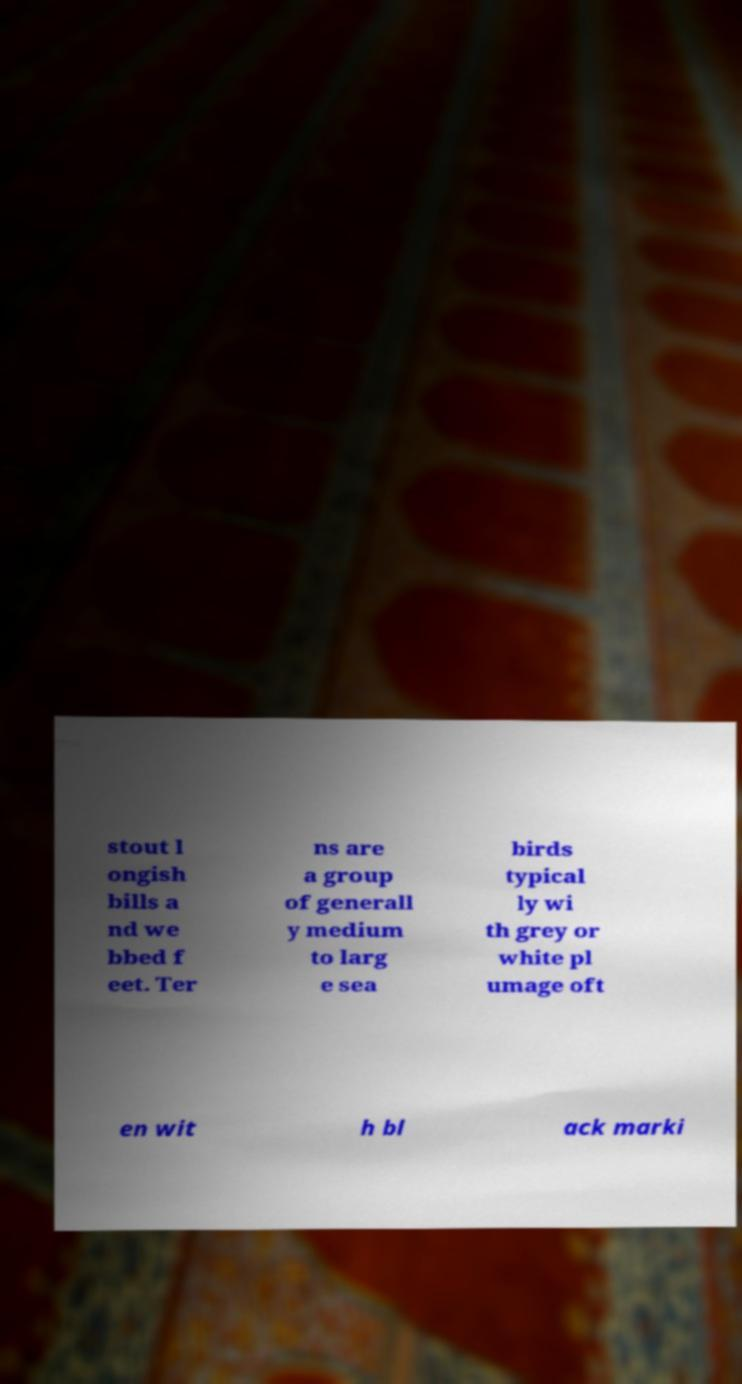Could you extract and type out the text from this image? stout l ongish bills a nd we bbed f eet. Ter ns are a group of generall y medium to larg e sea birds typical ly wi th grey or white pl umage oft en wit h bl ack marki 